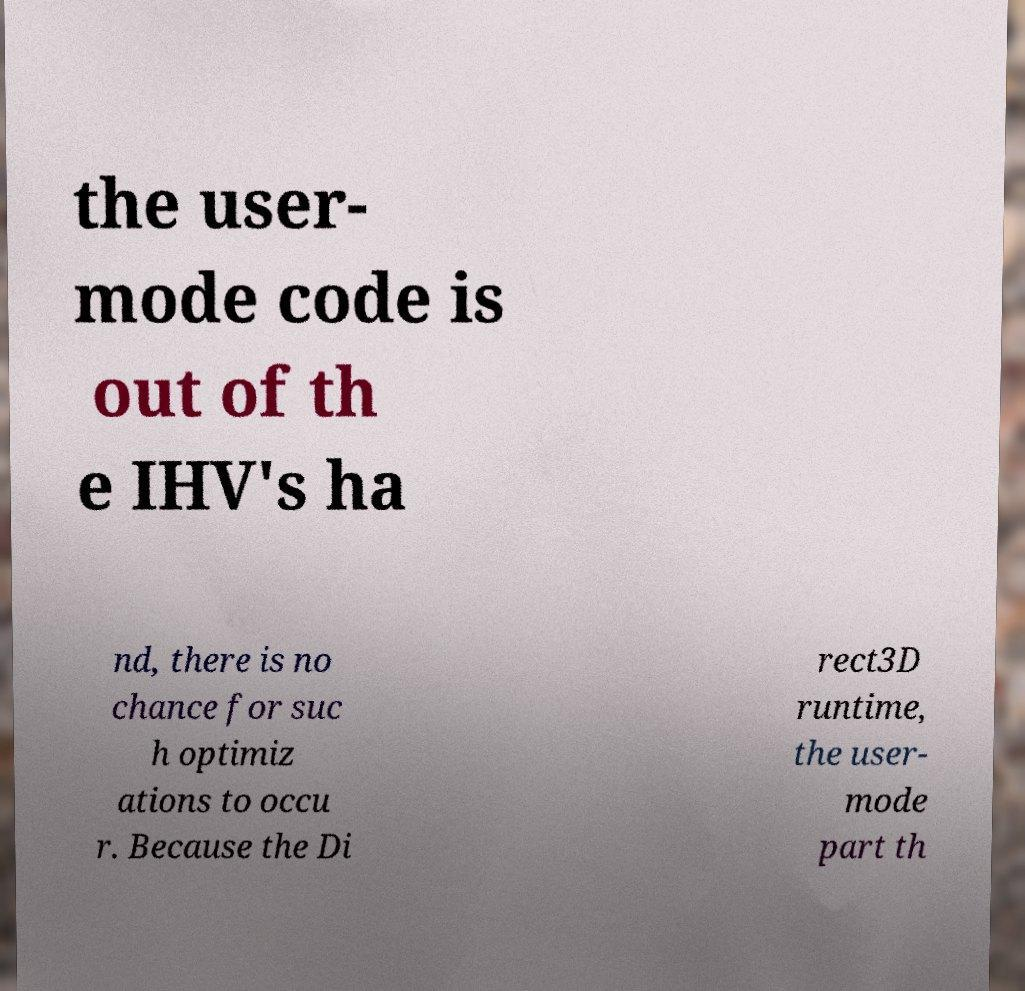Can you accurately transcribe the text from the provided image for me? the user- mode code is out of th e IHV's ha nd, there is no chance for suc h optimiz ations to occu r. Because the Di rect3D runtime, the user- mode part th 